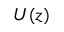<formula> <loc_0><loc_0><loc_500><loc_500>U ( z )</formula> 